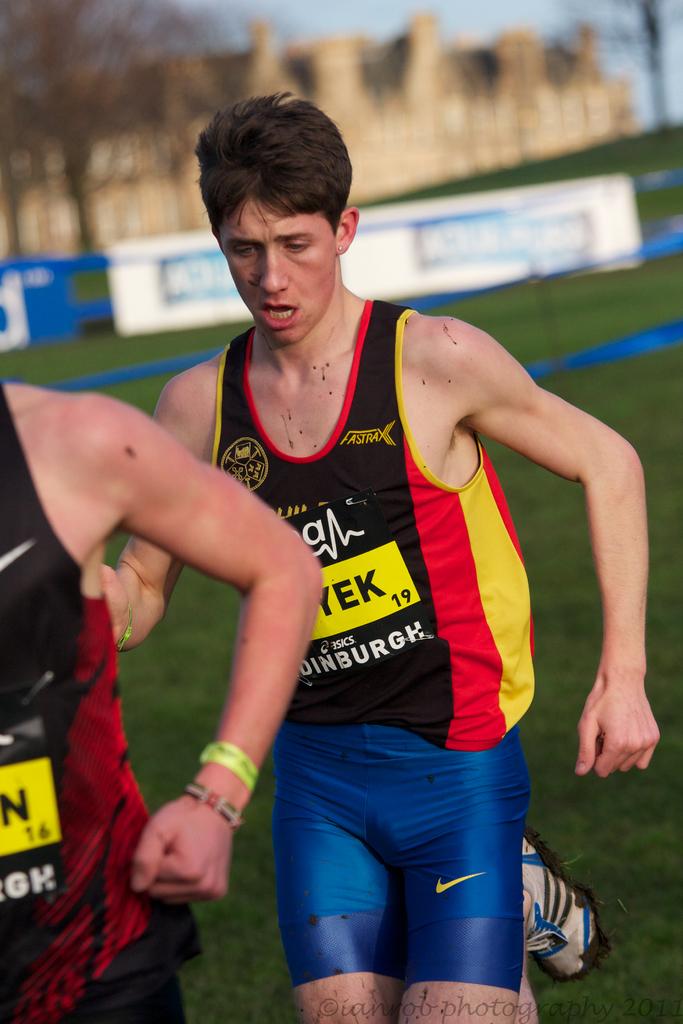What number is on the runner's jersey?
Provide a succinct answer. 19. 